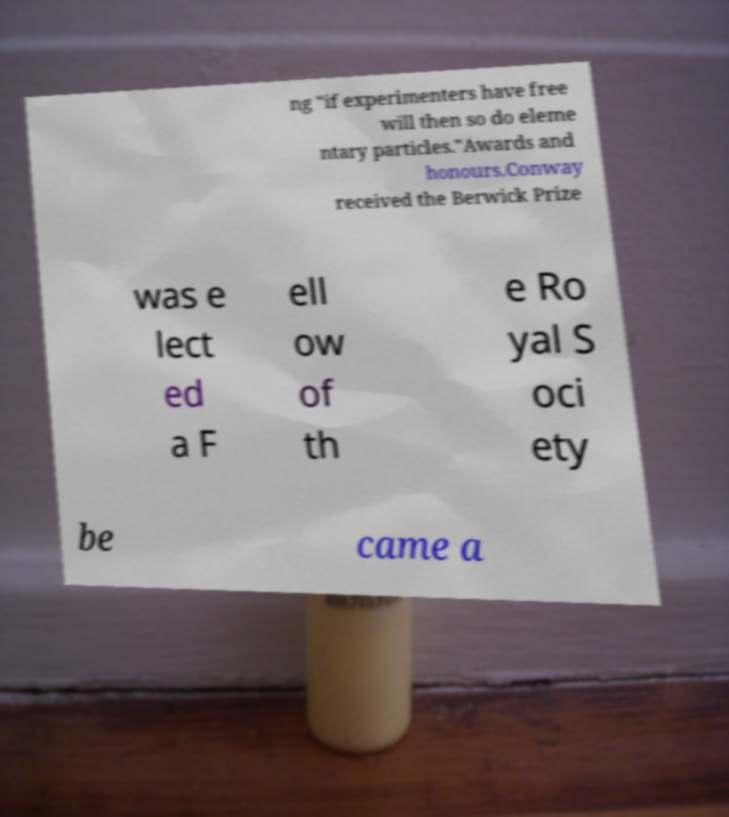Can you accurately transcribe the text from the provided image for me? ng "if experimenters have free will then so do eleme ntary particles."Awards and honours.Conway received the Berwick Prize was e lect ed a F ell ow of th e Ro yal S oci ety be came a 